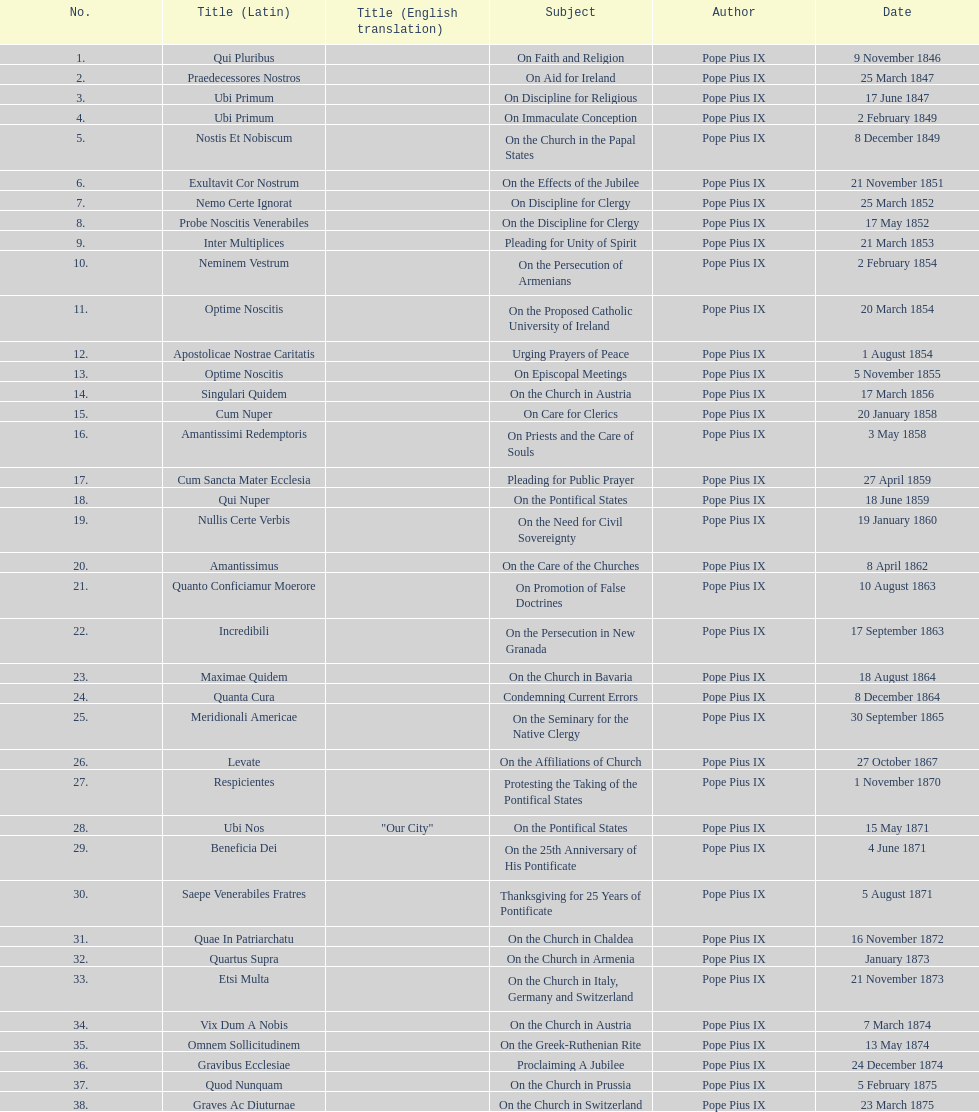Date of the last encyclical whose subject contained the word "pontificate" 5 August 1871. 